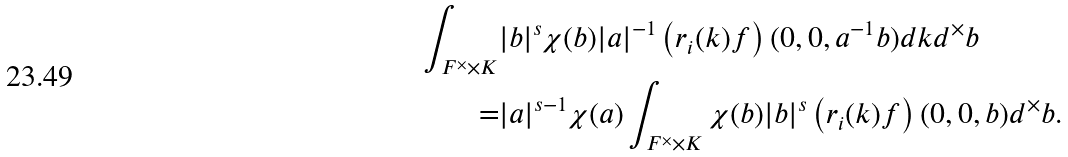<formula> <loc_0><loc_0><loc_500><loc_500>\int _ { F ^ { \times } \times K } & | b | ^ { s } \chi ( b ) | a | ^ { - 1 } \left ( r _ { i } ( k ) f \right ) ( 0 , 0 , a ^ { - 1 } b ) d k d ^ { \times } b \\ = & | a | ^ { s - 1 } \chi ( a ) \int _ { F ^ { \times } \times K } \chi ( b ) | b | ^ { s } \left ( r _ { i } ( k ) f \right ) ( 0 , 0 , b ) d ^ { \times } b .</formula> 